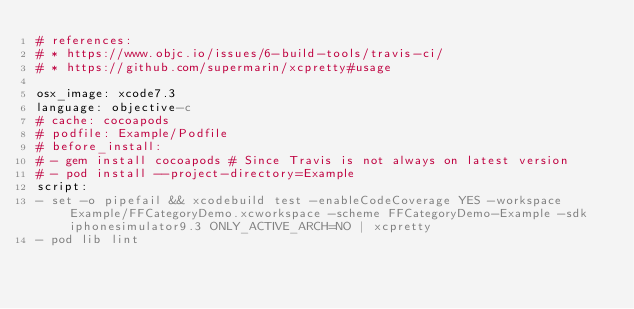Convert code to text. <code><loc_0><loc_0><loc_500><loc_500><_YAML_># references:
# * https://www.objc.io/issues/6-build-tools/travis-ci/
# * https://github.com/supermarin/xcpretty#usage

osx_image: xcode7.3
language: objective-c
# cache: cocoapods
# podfile: Example/Podfile
# before_install:
# - gem install cocoapods # Since Travis is not always on latest version
# - pod install --project-directory=Example
script:
- set -o pipefail && xcodebuild test -enableCodeCoverage YES -workspace Example/FFCategoryDemo.xcworkspace -scheme FFCategoryDemo-Example -sdk iphonesimulator9.3 ONLY_ACTIVE_ARCH=NO | xcpretty
- pod lib lint
</code> 